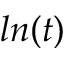Convert formula to latex. <formula><loc_0><loc_0><loc_500><loc_500>\ln ( t )</formula> 